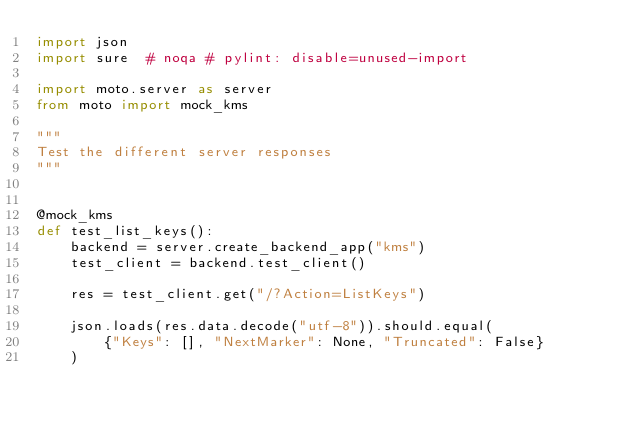Convert code to text. <code><loc_0><loc_0><loc_500><loc_500><_Python_>import json
import sure  # noqa # pylint: disable=unused-import

import moto.server as server
from moto import mock_kms

"""
Test the different server responses
"""


@mock_kms
def test_list_keys():
    backend = server.create_backend_app("kms")
    test_client = backend.test_client()

    res = test_client.get("/?Action=ListKeys")

    json.loads(res.data.decode("utf-8")).should.equal(
        {"Keys": [], "NextMarker": None, "Truncated": False}
    )
</code> 